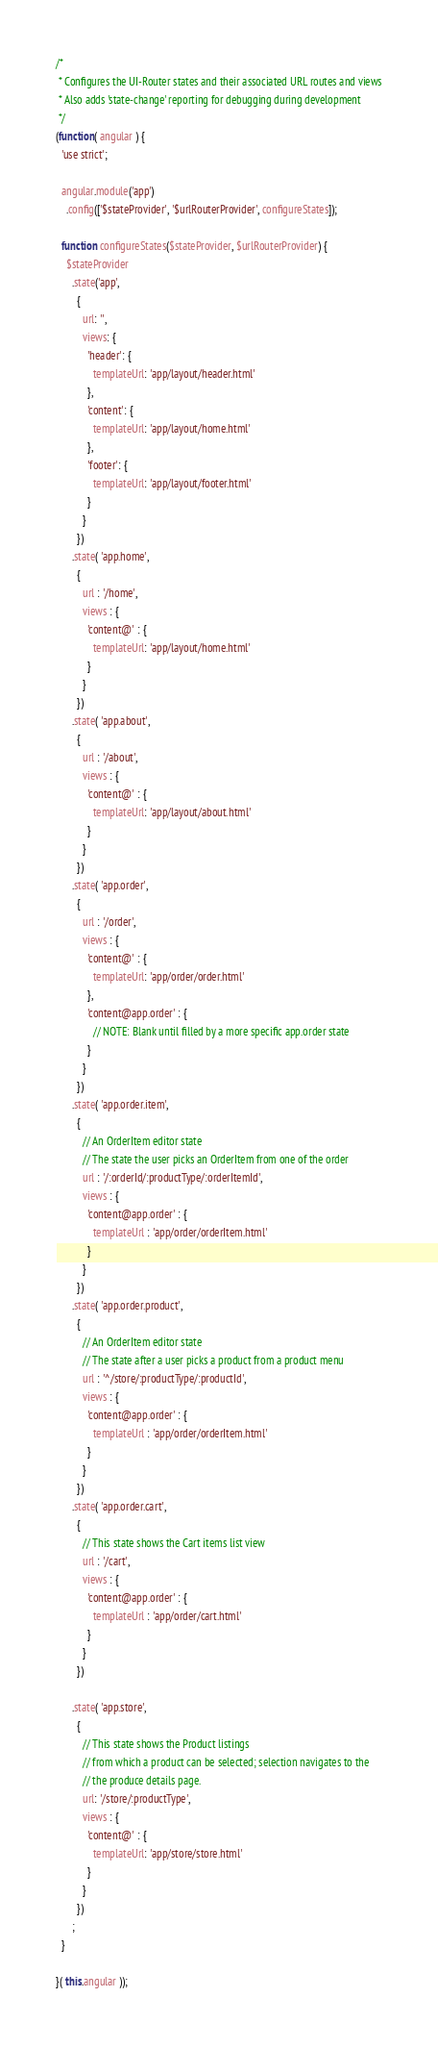<code> <loc_0><loc_0><loc_500><loc_500><_JavaScript_>/*
 * Configures the UI-Router states and their associated URL routes and views
 * Also adds 'state-change' reporting for debugging during development
 */
(function( angular ) {
  'use strict';

  angular.module('app')
    .config(['$stateProvider', '$urlRouterProvider', configureStates]);

  function configureStates($stateProvider, $urlRouterProvider) {
    $stateProvider
      .state('app',
        {
          url: '',
          views: {
            'header': {
              templateUrl: 'app/layout/header.html'
            },
            'content': {
              templateUrl: 'app/layout/home.html'
            },
            'footer': {
              templateUrl: 'app/layout/footer.html'
            }
          }
        })
      .state( 'app.home',
        {
          url : '/home',
          views : {
            'content@' : {
              templateUrl: 'app/layout/home.html'
            }
          }
        })
      .state( 'app.about',
        {
          url : '/about',
          views : {
            'content@' : {
              templateUrl: 'app/layout/about.html'
            }
          }
        })
      .state( 'app.order',
        {
          url : '/order',
          views : {
            'content@' : {
              templateUrl: 'app/order/order.html'
            },
            'content@app.order' : {
              // NOTE: Blank until filled by a more specific app.order state
            }
          }
        })
      .state( 'app.order.item',
        {
          // An OrderItem editor state
          // The state the user picks an OrderItem from one of the order
          url : '/:orderId/:productType/:orderItemId',
          views : {
            'content@app.order' : {
              templateUrl : 'app/order/orderItem.html'
            }
          }
        })
      .state( 'app.order.product',
        {
          // An OrderItem editor state
          // The state after a user picks a product from a product menu
          url : '^/store/:productType/:productId',
          views : {
            'content@app.order' : {
              templateUrl : 'app/order/orderItem.html'
            }
          }
        })
      .state( 'app.order.cart',
        {
          // This state shows the Cart items list view
          url : '/cart',
          views : {
            'content@app.order' : {
              templateUrl : 'app/order/cart.html'
            }
          }
        })

      .state( 'app.store',
        {
          // This state shows the Product listings
          // from which a product can be selected; selection navigates to the
          // the produce details page.
          url: '/store/:productType',
          views : {
            'content@' : {
              templateUrl: 'app/store/store.html'
            }
          }
        })
      ;
  }

}( this.angular ));</code> 